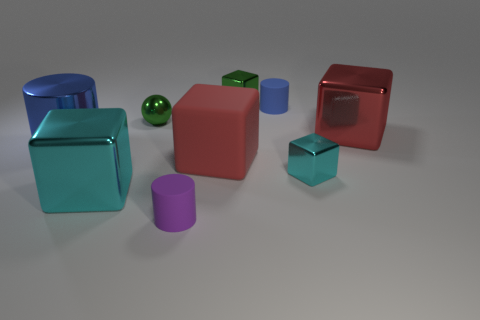Subtract all tiny green blocks. How many blocks are left? 4 Subtract all green blocks. How many blocks are left? 4 Add 1 tiny blue things. How many objects exist? 10 Subtract all red spheres. Subtract all blue cylinders. How many spheres are left? 1 Subtract all spheres. How many objects are left? 8 Subtract 1 green blocks. How many objects are left? 8 Subtract all green shiny balls. Subtract all big rubber objects. How many objects are left? 7 Add 6 small shiny things. How many small shiny things are left? 9 Add 6 green metallic things. How many green metallic things exist? 8 